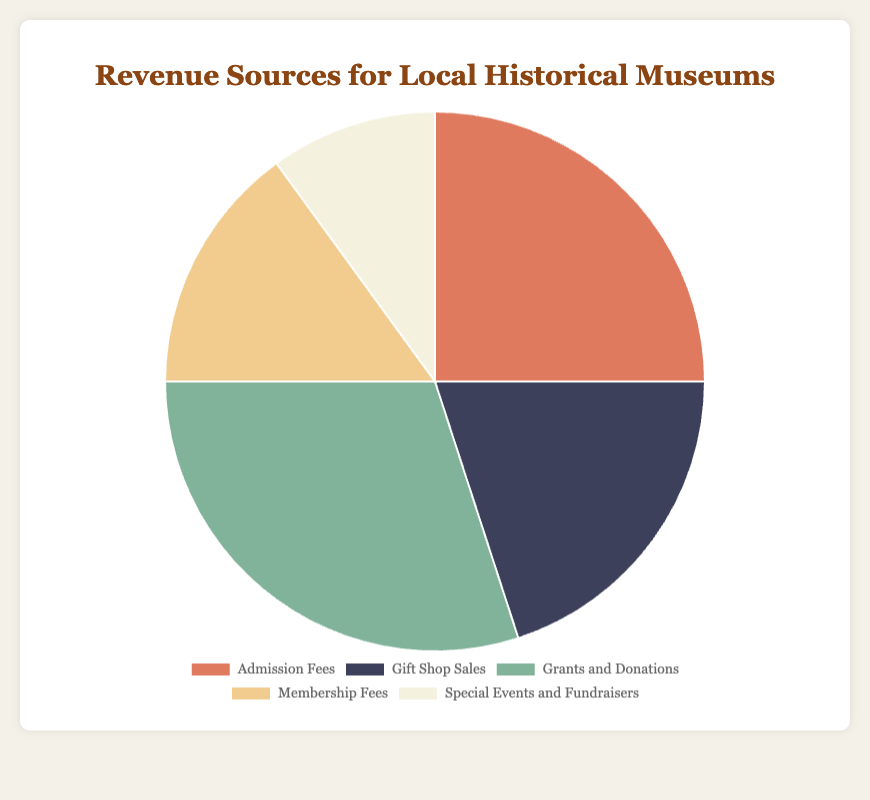Which source contributes the most to the revenue for local historical museums? The segment labeled "Grants and Donations" occupies the largest proportion of the pie chart, indicating that it contributes the most.
Answer: Grants and Donations Which source contributes the least to the revenue for local historical museums? The segment labeled "Special Events and Fundraisers" is the smallest, indicating it contributes the least.
Answer: Special Events and Fundraisers What is the combined percentage of revenue from 'Admission Fees' and 'Gift Shop Sales'? 'Admission Fees' contributes 25% and 'Gift Shop Sales' contributes 20%. Combining these gives 25% + 20% = 45%.
Answer: 45% Is the revenue from 'Membership Fees' greater than 'Special Events and Fundraisers'? The segment labeled 'Membership Fees' is 15%, which is greater than the 10% for 'Special Events and Fundraisers'.
Answer: Yes What percentage of the revenue comes from sources other than 'Grants and Donations'? The percentage for 'Grants and Donations' is 30%. The total percentage of all sources is 100%, so subtracting 'Grants and Donations' gives 100% - 30% = 70%.
Answer: 70% Which source's contribution is closest to that of 'Gift Shop Sales'? 'Gift Shop Sales' is 20%. 'Membership Fees' is 15%, which is the closest to 20%.
Answer: Membership Fees How much more revenue does 'Grants and Donations' contribute compared to 'Admission Fees'? 'Grants and Donations' contributes 30% and 'Admission Fees' contribute 25%. The difference is 30% - 25% = 5%.
Answer: 5% How much more do 'Admission Fees' and 'Gift Shop Sales' combined contribute compared to 'Membership Fees' and 'Special Events and Fundraisers' combined? 'Admission Fees' and 'Gift Shop Sales' combined contribute 45% (25% + 20%). 'Membership Fees' and 'Special Events and Fundraisers' combined contribute 25% (15% + 10%). The difference is 45% - 25% = 20%.
Answer: 20% Which segment is represented by a green color? The visual attribute of the green color corresponds to the segment labeled 'Grants and Donations'.
Answer: Grants and Donations 